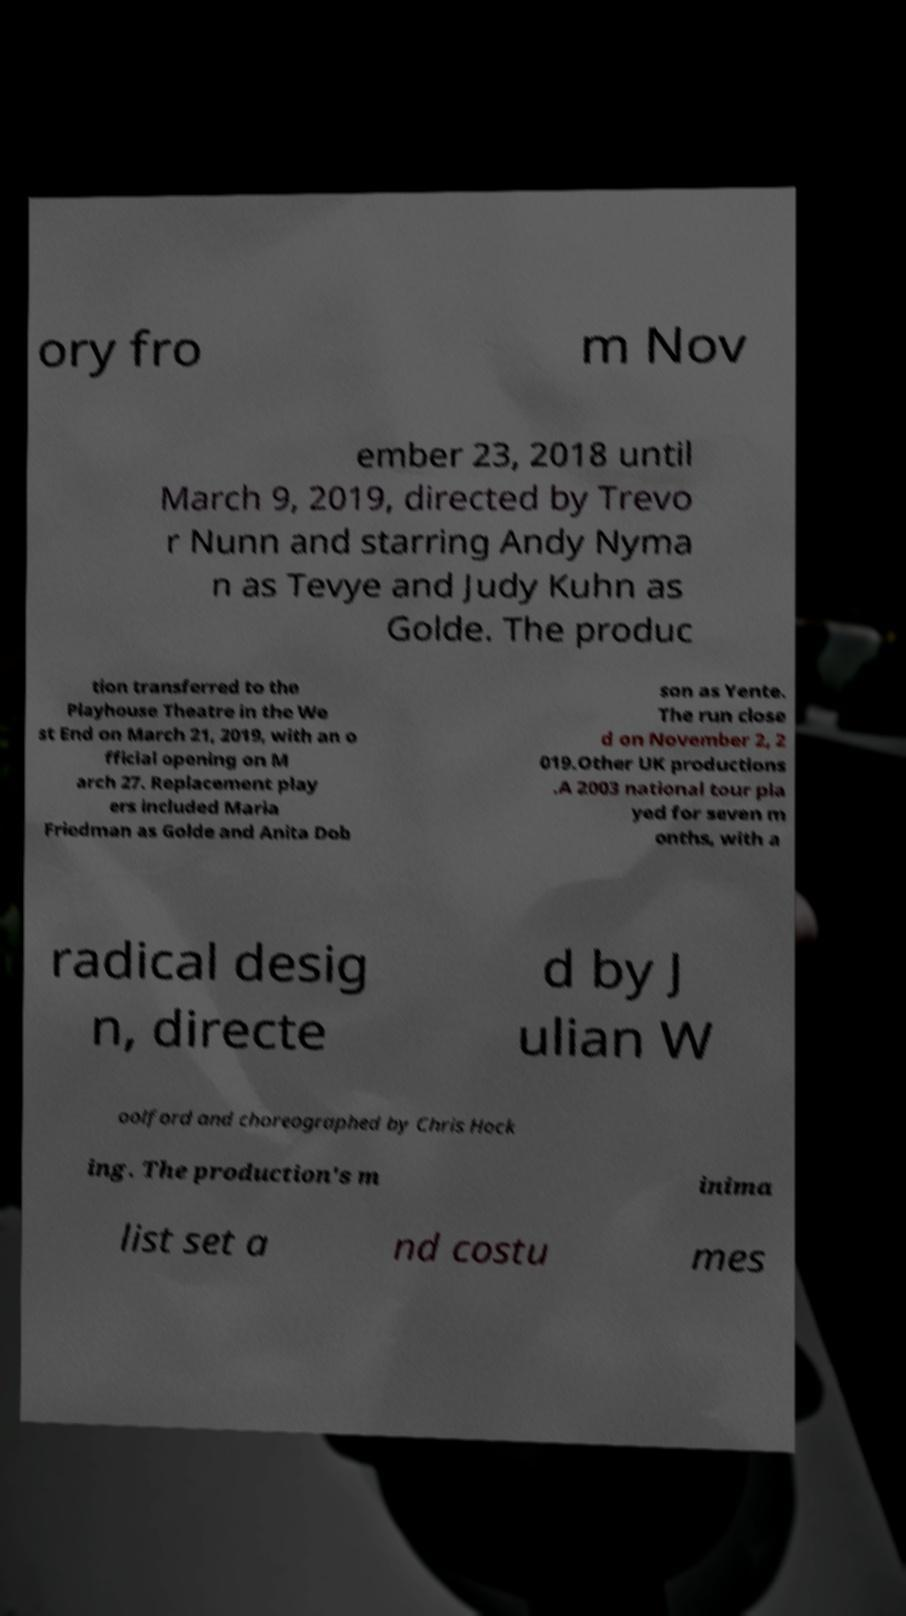For documentation purposes, I need the text within this image transcribed. Could you provide that? ory fro m Nov ember 23, 2018 until March 9, 2019, directed by Trevo r Nunn and starring Andy Nyma n as Tevye and Judy Kuhn as Golde. The produc tion transferred to the Playhouse Theatre in the We st End on March 21, 2019, with an o fficial opening on M arch 27. Replacement play ers included Maria Friedman as Golde and Anita Dob son as Yente. The run close d on November 2, 2 019.Other UK productions .A 2003 national tour pla yed for seven m onths, with a radical desig n, directe d by J ulian W oolford and choreographed by Chris Hock ing. The production's m inima list set a nd costu mes 